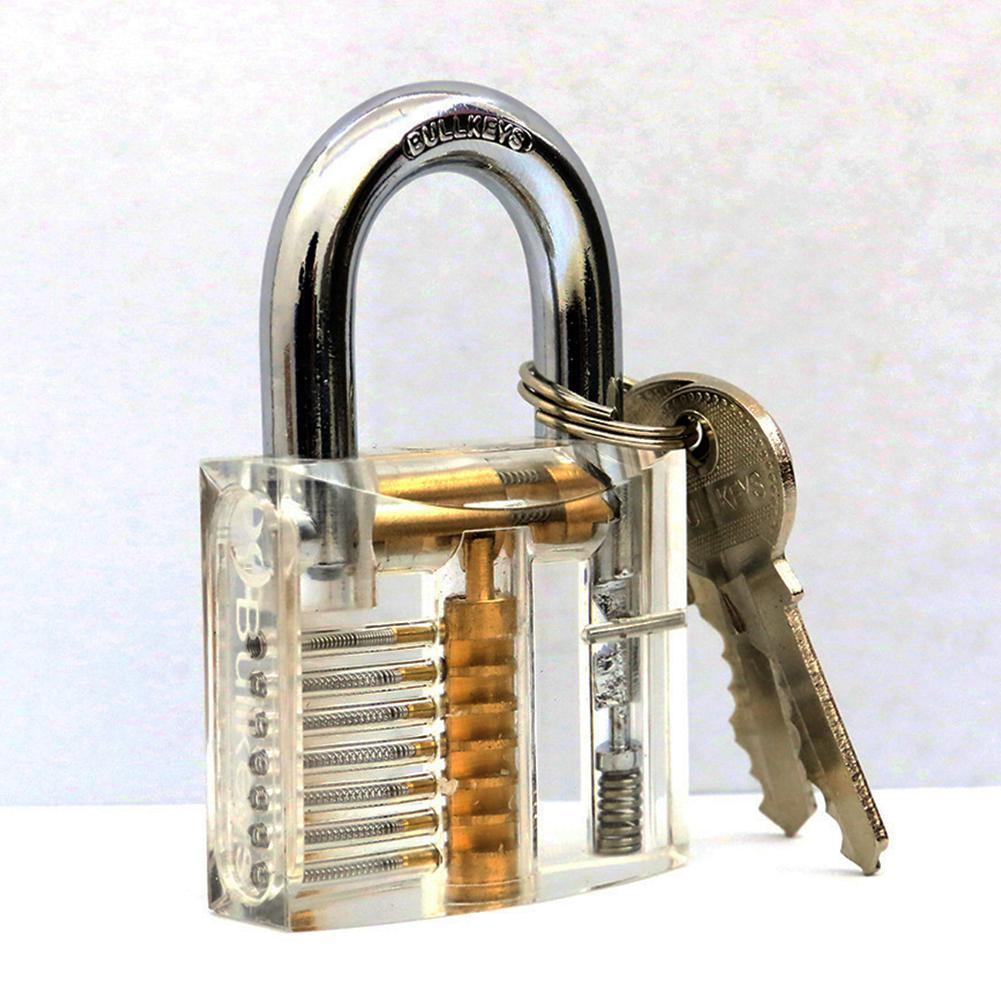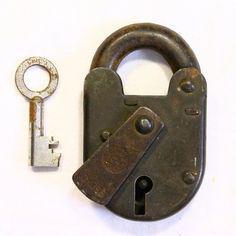The first image is the image on the left, the second image is the image on the right. Evaluate the accuracy of this statement regarding the images: "There are at least 3 keys present, next to locks.". Is it true? Answer yes or no. Yes. 